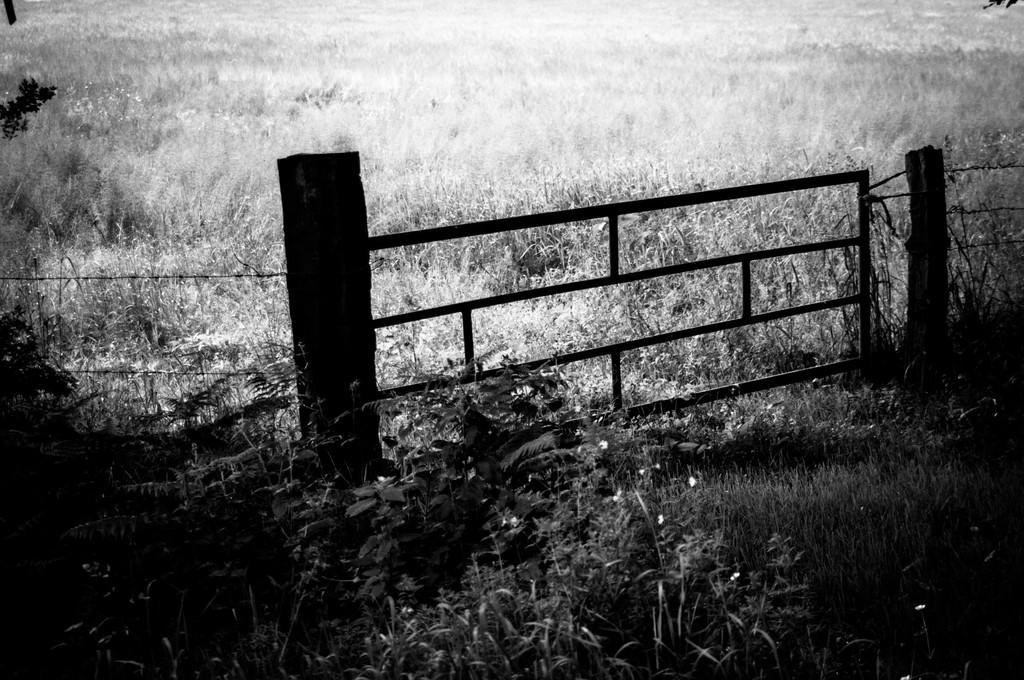What is the color scheme of the image? The image is black and white. What can be seen in the middle of the image? There is a fence in the middle of the image. What type of vegetation is at the bottom of the image? There is grass at the bottom of the image. How many thumbs can be seen in the image? There are no thumbs present in the image. What type of cushion is placed on the grass in the image? There is no cushion present in the image; it only features a fence and grass. 